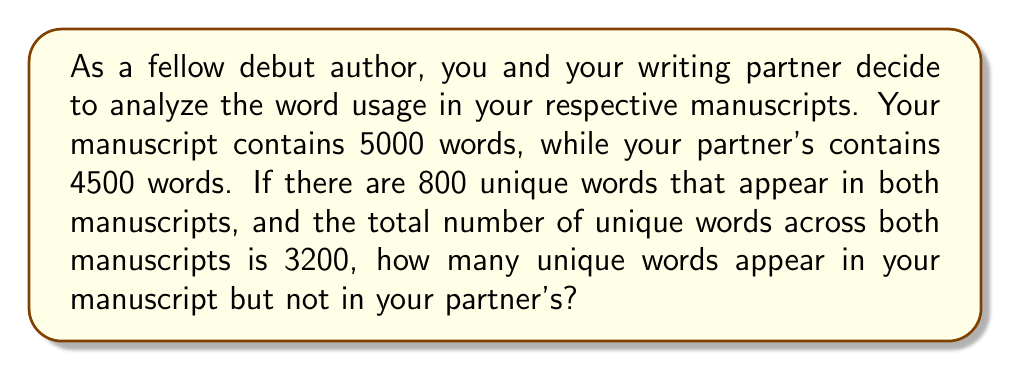Provide a solution to this math problem. Let's approach this problem using set theory:

1) Let A be the set of unique words in your manuscript
2) Let B be the set of unique words in your partner's manuscript

We know:
- $|A \cup B| = 3200$ (total unique words across both manuscripts)
- $|A \cap B| = 800$ (unique words that appear in both manuscripts)

We need to find $|A \setminus B|$ (unique words in your manuscript but not in your partner's)

Using the principle of inclusion-exclusion:

$$ |A \cup B| = |A| + |B| - |A \cap B| $$

Substituting the known values:

$$ 3200 = |A| + |B| - 800 $$
$$ 4000 = |A| + |B| $$

Now, we need to find $|A|$. We can't determine this exactly, but we know $|A|$ must be less than or equal to 5000 (the total words in your manuscript).

Let's assume each unique word appears only once in each manuscript (worst case scenario for uniqueness). Then:

$$ |A| \leq 5000 $$
$$ |B| \leq 4500 $$

Given $|A| + |B| = 4000$, the maximum possible value for $|A|$ is 2200 and for $|B|$ is 1800.

Therefore:

$$ |A| = 2200 $$
$$ |B| = 1800 $$

Now we can calculate $|A \setminus B|$:

$$ |A \setminus B| = |A| - |A \cap B| = 2200 - 800 = 1400 $$
Answer: 1400 unique words appear in your manuscript but not in your partner's. 